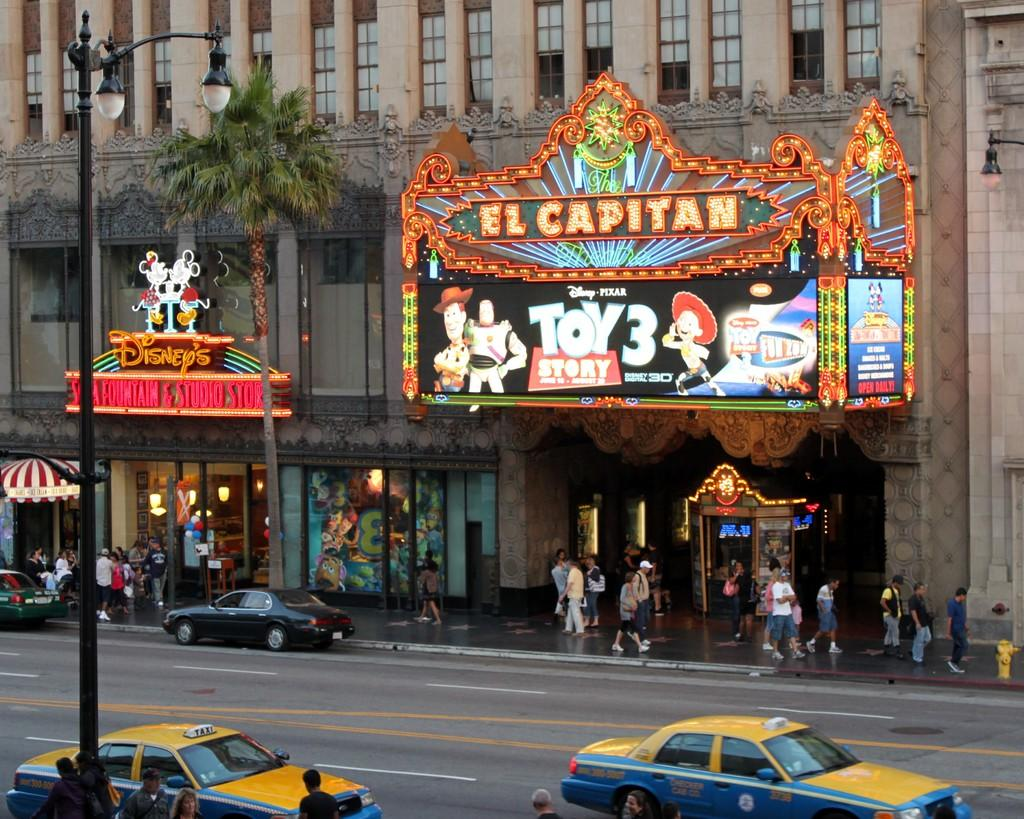<image>
Summarize the visual content of the image. Toy Story 3 is playing at the El Capitan theater. 